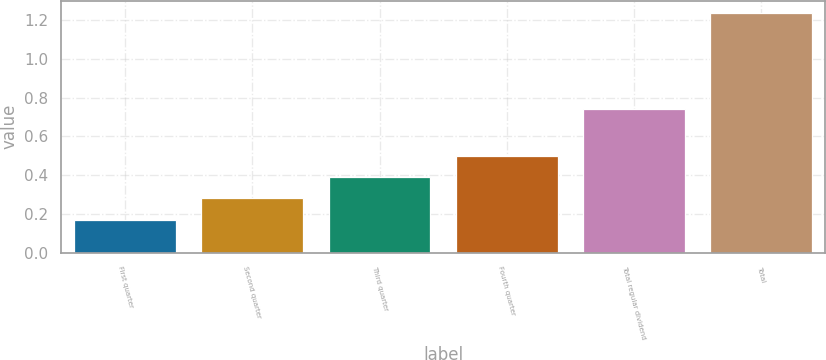Convert chart to OTSL. <chart><loc_0><loc_0><loc_500><loc_500><bar_chart><fcel>First quarter<fcel>Second quarter<fcel>Third quarter<fcel>Fourth quarter<fcel>Total regular dividend<fcel>Total<nl><fcel>0.17<fcel>0.28<fcel>0.39<fcel>0.5<fcel>0.74<fcel>1.24<nl></chart> 